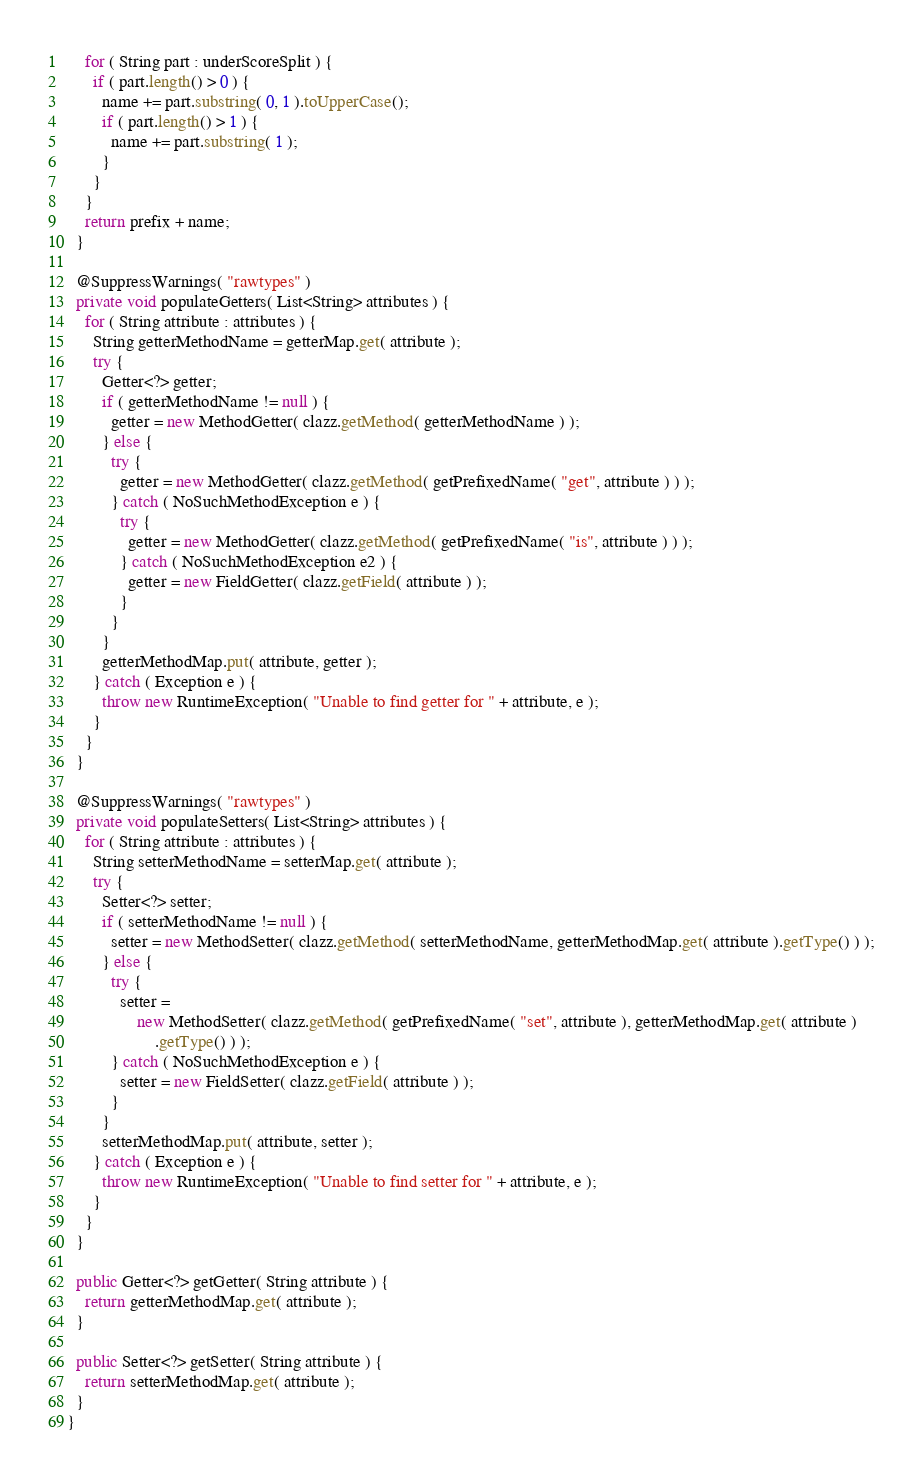<code> <loc_0><loc_0><loc_500><loc_500><_Java_>    for ( String part : underScoreSplit ) {
      if ( part.length() > 0 ) {
        name += part.substring( 0, 1 ).toUpperCase();
        if ( part.length() > 1 ) {
          name += part.substring( 1 );
        }
      }
    }
    return prefix + name;
  }

  @SuppressWarnings( "rawtypes" )
  private void populateGetters( List<String> attributes ) {
    for ( String attribute : attributes ) {
      String getterMethodName = getterMap.get( attribute );
      try {
        Getter<?> getter;
        if ( getterMethodName != null ) {
          getter = new MethodGetter( clazz.getMethod( getterMethodName ) );
        } else {
          try {
            getter = new MethodGetter( clazz.getMethod( getPrefixedName( "get", attribute ) ) );
          } catch ( NoSuchMethodException e ) {
            try {
              getter = new MethodGetter( clazz.getMethod( getPrefixedName( "is", attribute ) ) );
            } catch ( NoSuchMethodException e2 ) {
              getter = new FieldGetter( clazz.getField( attribute ) );
            }
          }
        }
        getterMethodMap.put( attribute, getter );
      } catch ( Exception e ) {
        throw new RuntimeException( "Unable to find getter for " + attribute, e );
      }
    }
  }

  @SuppressWarnings( "rawtypes" )
  private void populateSetters( List<String> attributes ) {
    for ( String attribute : attributes ) {
      String setterMethodName = setterMap.get( attribute );
      try {
        Setter<?> setter;
        if ( setterMethodName != null ) {
          setter = new MethodSetter( clazz.getMethod( setterMethodName, getterMethodMap.get( attribute ).getType() ) );
        } else {
          try {
            setter =
                new MethodSetter( clazz.getMethod( getPrefixedName( "set", attribute ), getterMethodMap.get( attribute )
                    .getType() ) );
          } catch ( NoSuchMethodException e ) {
            setter = new FieldSetter( clazz.getField( attribute ) );
          }
        }
        setterMethodMap.put( attribute, setter );
      } catch ( Exception e ) {
        throw new RuntimeException( "Unable to find setter for " + attribute, e );
      }
    }
  }

  public Getter<?> getGetter( String attribute ) {
    return getterMethodMap.get( attribute );
  }

  public Setter<?> getSetter( String attribute ) {
    return setterMethodMap.get( attribute );
  }
}
</code> 